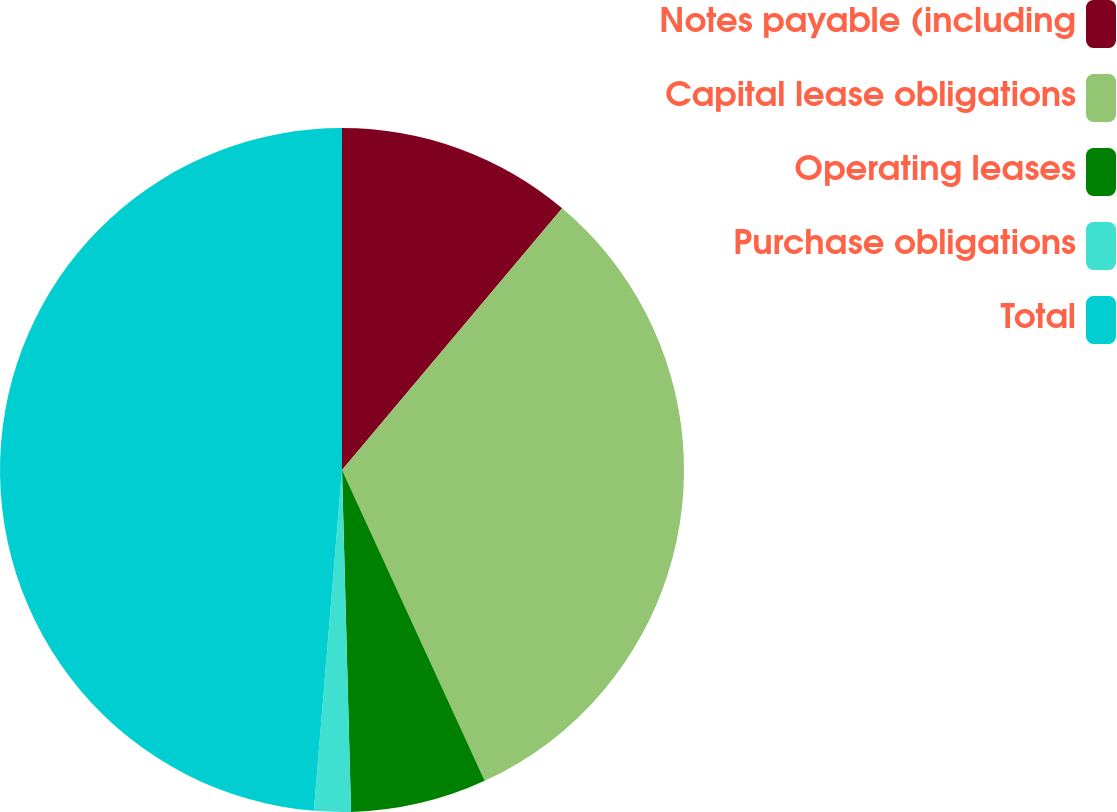<chart> <loc_0><loc_0><loc_500><loc_500><pie_chart><fcel>Notes payable (including<fcel>Capital lease obligations<fcel>Operating leases<fcel>Purchase obligations<fcel>Total<nl><fcel>11.13%<fcel>32.02%<fcel>6.43%<fcel>1.73%<fcel>48.69%<nl></chart> 